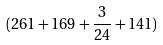Convert formula to latex. <formula><loc_0><loc_0><loc_500><loc_500>( 2 6 1 + 1 6 9 + \frac { 3 } { 2 4 } + 1 4 1 )</formula> 